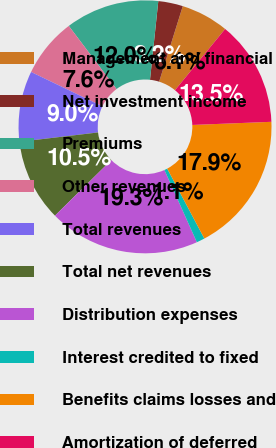<chart> <loc_0><loc_0><loc_500><loc_500><pie_chart><fcel>Management and financial<fcel>Net investment income<fcel>Premiums<fcel>Other revenues<fcel>Total revenues<fcel>Total net revenues<fcel>Distribution expenses<fcel>Interest credited to fixed<fcel>Benefits claims losses and<fcel>Amortization of deferred<nl><fcel>6.09%<fcel>3.15%<fcel>11.97%<fcel>7.56%<fcel>9.03%<fcel>10.5%<fcel>19.33%<fcel>1.05%<fcel>17.86%<fcel>13.45%<nl></chart> 